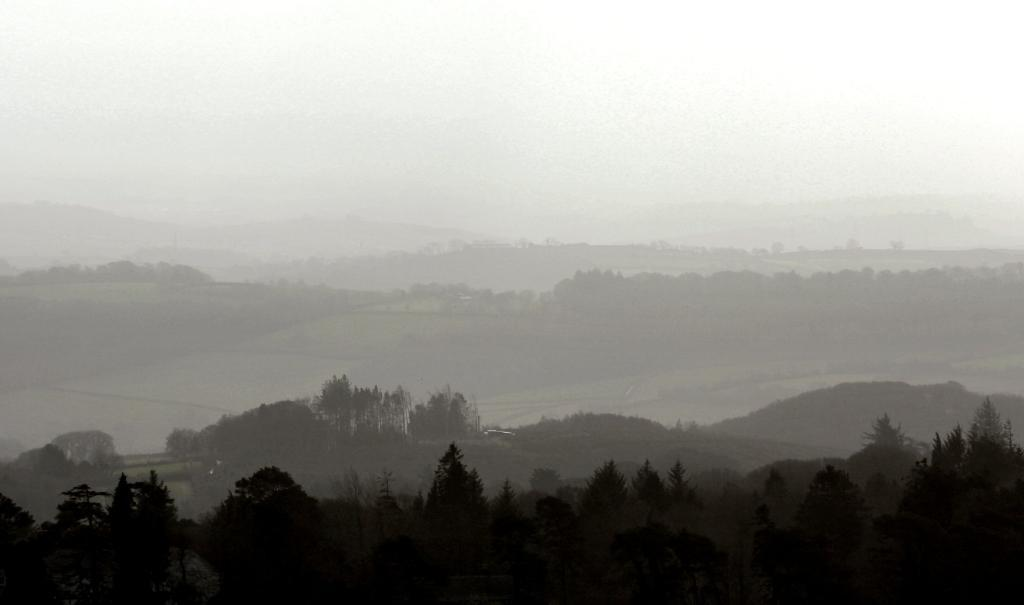What type of view is shown in the image? The image is an aerial view. What can be seen in the foreground of the image? There are many trees and plants in the front of the image. What is visible in the background of the image? There are mountains in the background of the image. How would you describe the sky in the image? The sky appears cloudy in the image. Can you see any quartz formations in the image? There is no mention of quartz formations in the provided facts, so it cannot be determined if they are present in the image. 